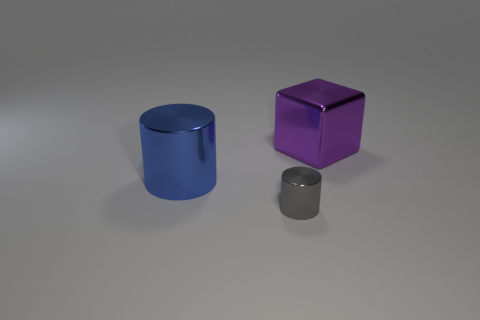Add 3 big purple shiny cubes. How many objects exist? 6 Add 1 big blue metal spheres. How many big blue metal spheres exist? 1 Subtract 0 green cylinders. How many objects are left? 3 Subtract all cylinders. How many objects are left? 1 Subtract all tiny brown blocks. Subtract all large blocks. How many objects are left? 2 Add 2 purple metallic cubes. How many purple metallic cubes are left? 3 